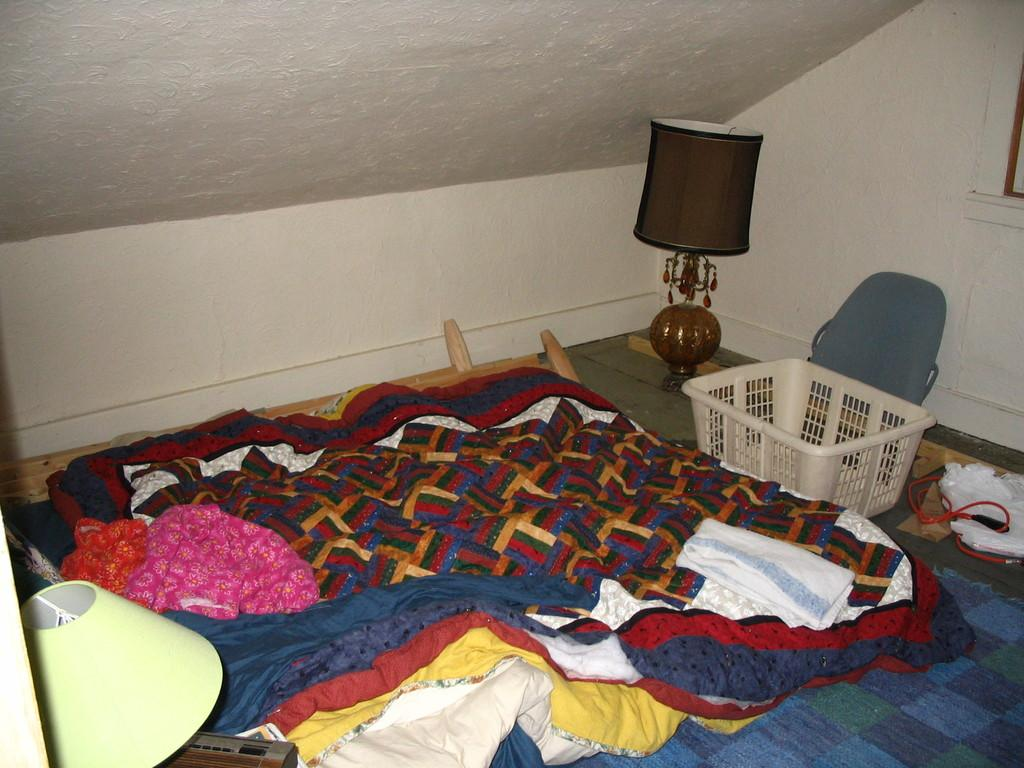What type of items can be seen in the image? There are clothes, a basket, and a lamp in the image. Can you describe the location of the basket? The basket is in the image. What might be used for illumination in the image? There is a lamp in the image for illumination. What else can be found on the floor in the image? There are other unspecified objects on the floor in the image. What type of creature is sitting on the clothes in the image? There is no creature present in the image; it only features clothes, a basket, a lamp, and unspecified objects on the floor. 